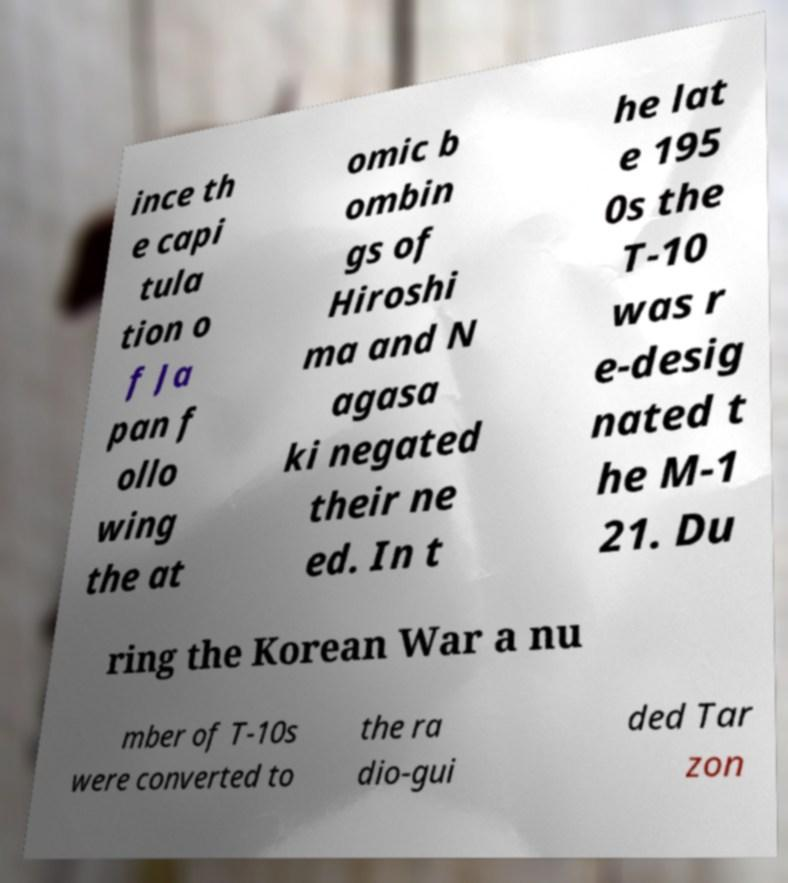Please read and relay the text visible in this image. What does it say? ince th e capi tula tion o f Ja pan f ollo wing the at omic b ombin gs of Hiroshi ma and N agasa ki negated their ne ed. In t he lat e 195 0s the T-10 was r e-desig nated t he M-1 21. Du ring the Korean War a nu mber of T-10s were converted to the ra dio-gui ded Tar zon 